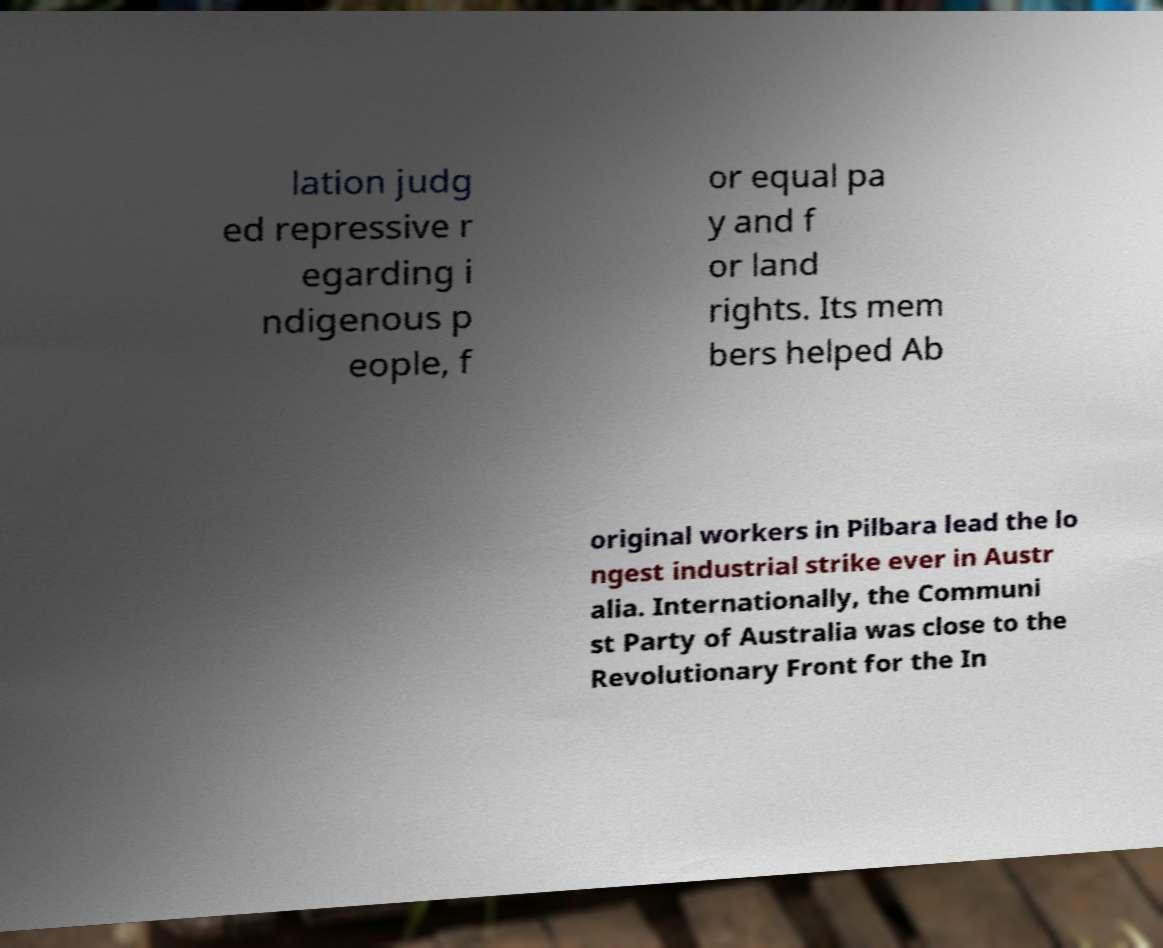What messages or text are displayed in this image? I need them in a readable, typed format. lation judg ed repressive r egarding i ndigenous p eople, f or equal pa y and f or land rights. Its mem bers helped Ab original workers in Pilbara lead the lo ngest industrial strike ever in Austr alia. Internationally, the Communi st Party of Australia was close to the Revolutionary Front for the In 